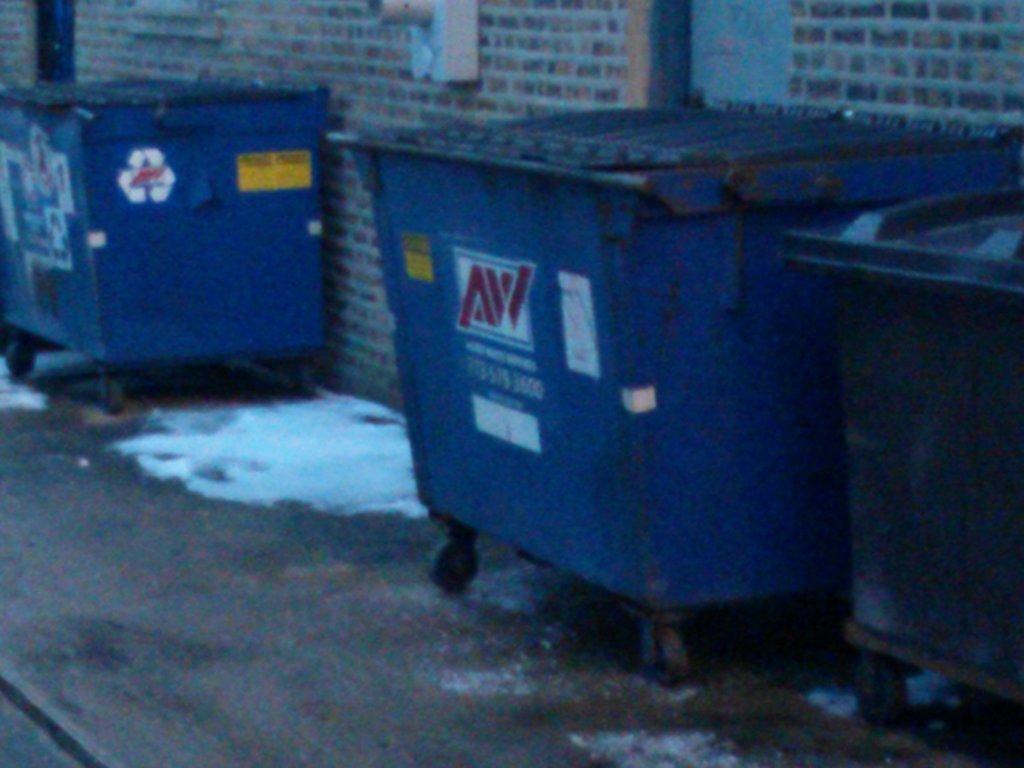What are the initials on the dumpster?
Make the answer very short. Aw. 